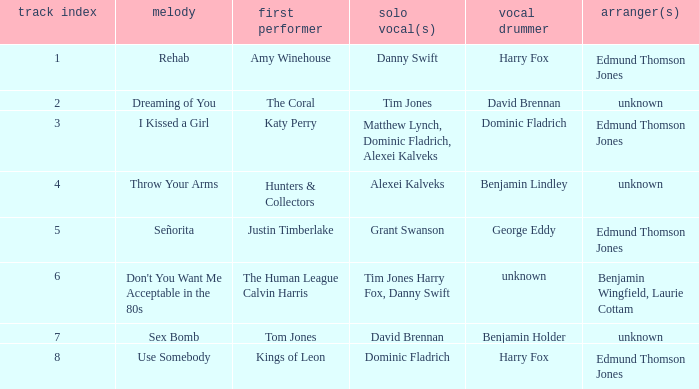Who is the original artist of "Use Somebody"? Kings of Leon. 